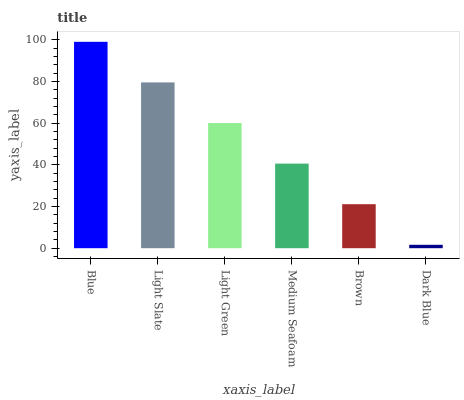Is Dark Blue the minimum?
Answer yes or no. Yes. Is Blue the maximum?
Answer yes or no. Yes. Is Light Slate the minimum?
Answer yes or no. No. Is Light Slate the maximum?
Answer yes or no. No. Is Blue greater than Light Slate?
Answer yes or no. Yes. Is Light Slate less than Blue?
Answer yes or no. Yes. Is Light Slate greater than Blue?
Answer yes or no. No. Is Blue less than Light Slate?
Answer yes or no. No. Is Light Green the high median?
Answer yes or no. Yes. Is Medium Seafoam the low median?
Answer yes or no. Yes. Is Blue the high median?
Answer yes or no. No. Is Blue the low median?
Answer yes or no. No. 